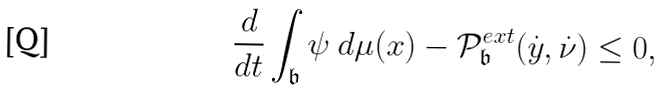<formula> <loc_0><loc_0><loc_500><loc_500>\frac { d } { d t } \int _ { \mathfrak { b } } \psi \text { } d \mu ( x ) - \mathcal { P } ^ { e x t } _ { \mathfrak { b } } ( \dot { y } , \dot { \nu } ) \leq 0 ,</formula> 